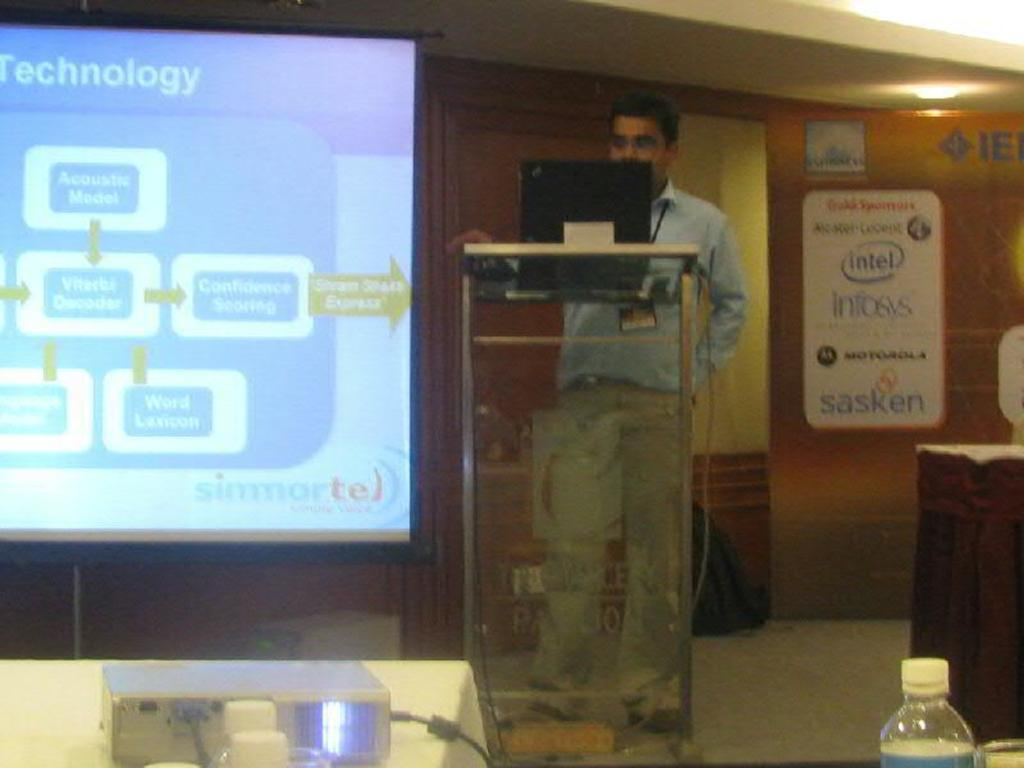<image>
Offer a succinct explanation of the picture presented. A man standing on a podium showing a slide about technology 